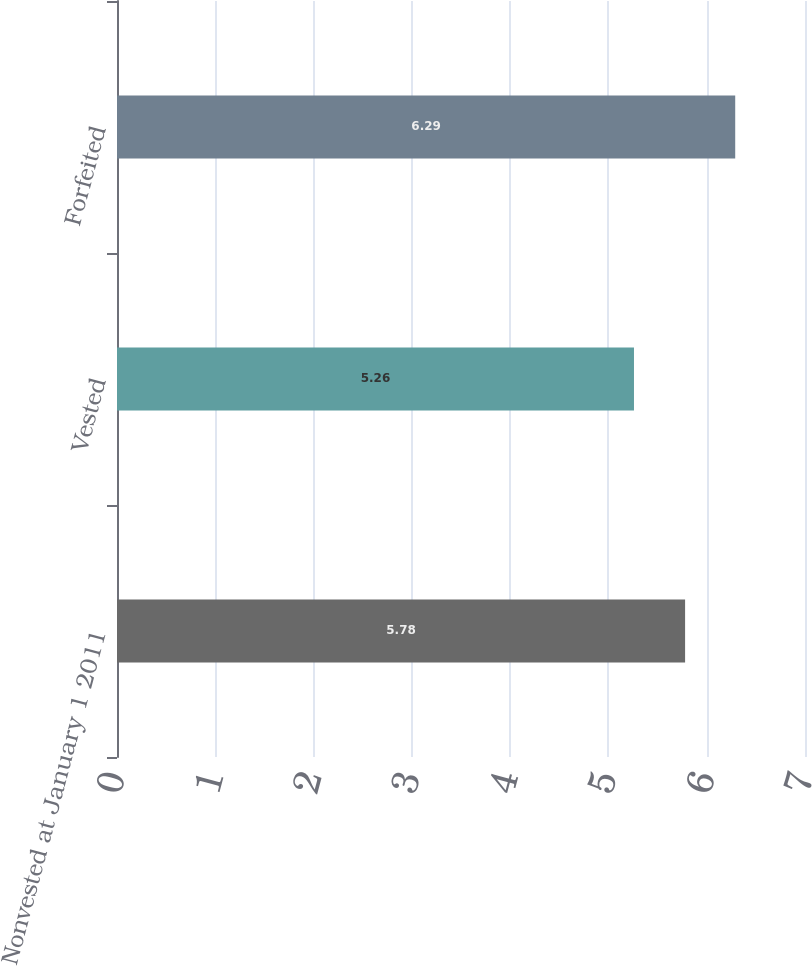Convert chart. <chart><loc_0><loc_0><loc_500><loc_500><bar_chart><fcel>Nonvested at January 1 2011<fcel>Vested<fcel>Forfeited<nl><fcel>5.78<fcel>5.26<fcel>6.29<nl></chart> 